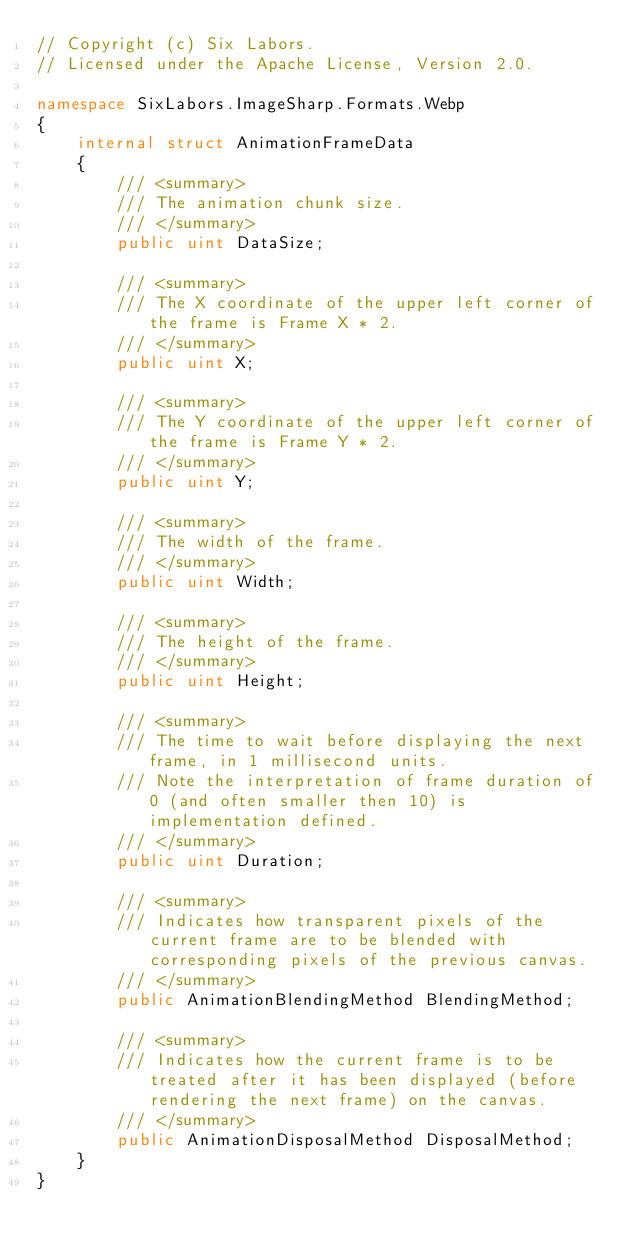Convert code to text. <code><loc_0><loc_0><loc_500><loc_500><_C#_>// Copyright (c) Six Labors.
// Licensed under the Apache License, Version 2.0.

namespace SixLabors.ImageSharp.Formats.Webp
{
    internal struct AnimationFrameData
    {
        /// <summary>
        /// The animation chunk size.
        /// </summary>
        public uint DataSize;

        /// <summary>
        /// The X coordinate of the upper left corner of the frame is Frame X * 2.
        /// </summary>
        public uint X;

        /// <summary>
        /// The Y coordinate of the upper left corner of the frame is Frame Y * 2.
        /// </summary>
        public uint Y;

        /// <summary>
        /// The width of the frame.
        /// </summary>
        public uint Width;

        /// <summary>
        /// The height of the frame.
        /// </summary>
        public uint Height;

        /// <summary>
        /// The time to wait before displaying the next frame, in 1 millisecond units.
        /// Note the interpretation of frame duration of 0 (and often smaller then 10) is implementation defined.
        /// </summary>
        public uint Duration;

        /// <summary>
        /// Indicates how transparent pixels of the current frame are to be blended with corresponding pixels of the previous canvas.
        /// </summary>
        public AnimationBlendingMethod BlendingMethod;

        /// <summary>
        /// Indicates how the current frame is to be treated after it has been displayed (before rendering the next frame) on the canvas.
        /// </summary>
        public AnimationDisposalMethod DisposalMethod;
    }
}
</code> 